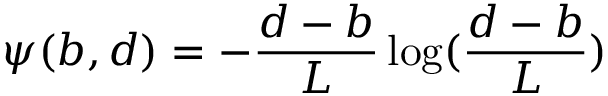<formula> <loc_0><loc_0><loc_500><loc_500>\psi ( b , d ) = - \frac { d - b } { L } \log ( \frac { d - b } { L } )</formula> 